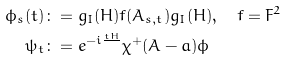Convert formula to latex. <formula><loc_0><loc_0><loc_500><loc_500>\phi _ { s } ( t ) & \colon = g _ { I } ( H ) f ( A _ { s , t } ) g _ { I } ( H ) , \quad f = F ^ { 2 } \\ \psi _ { t } & \colon = e ^ { - i \frac { t H } { } } \chi ^ { + } ( A - a ) \phi</formula> 